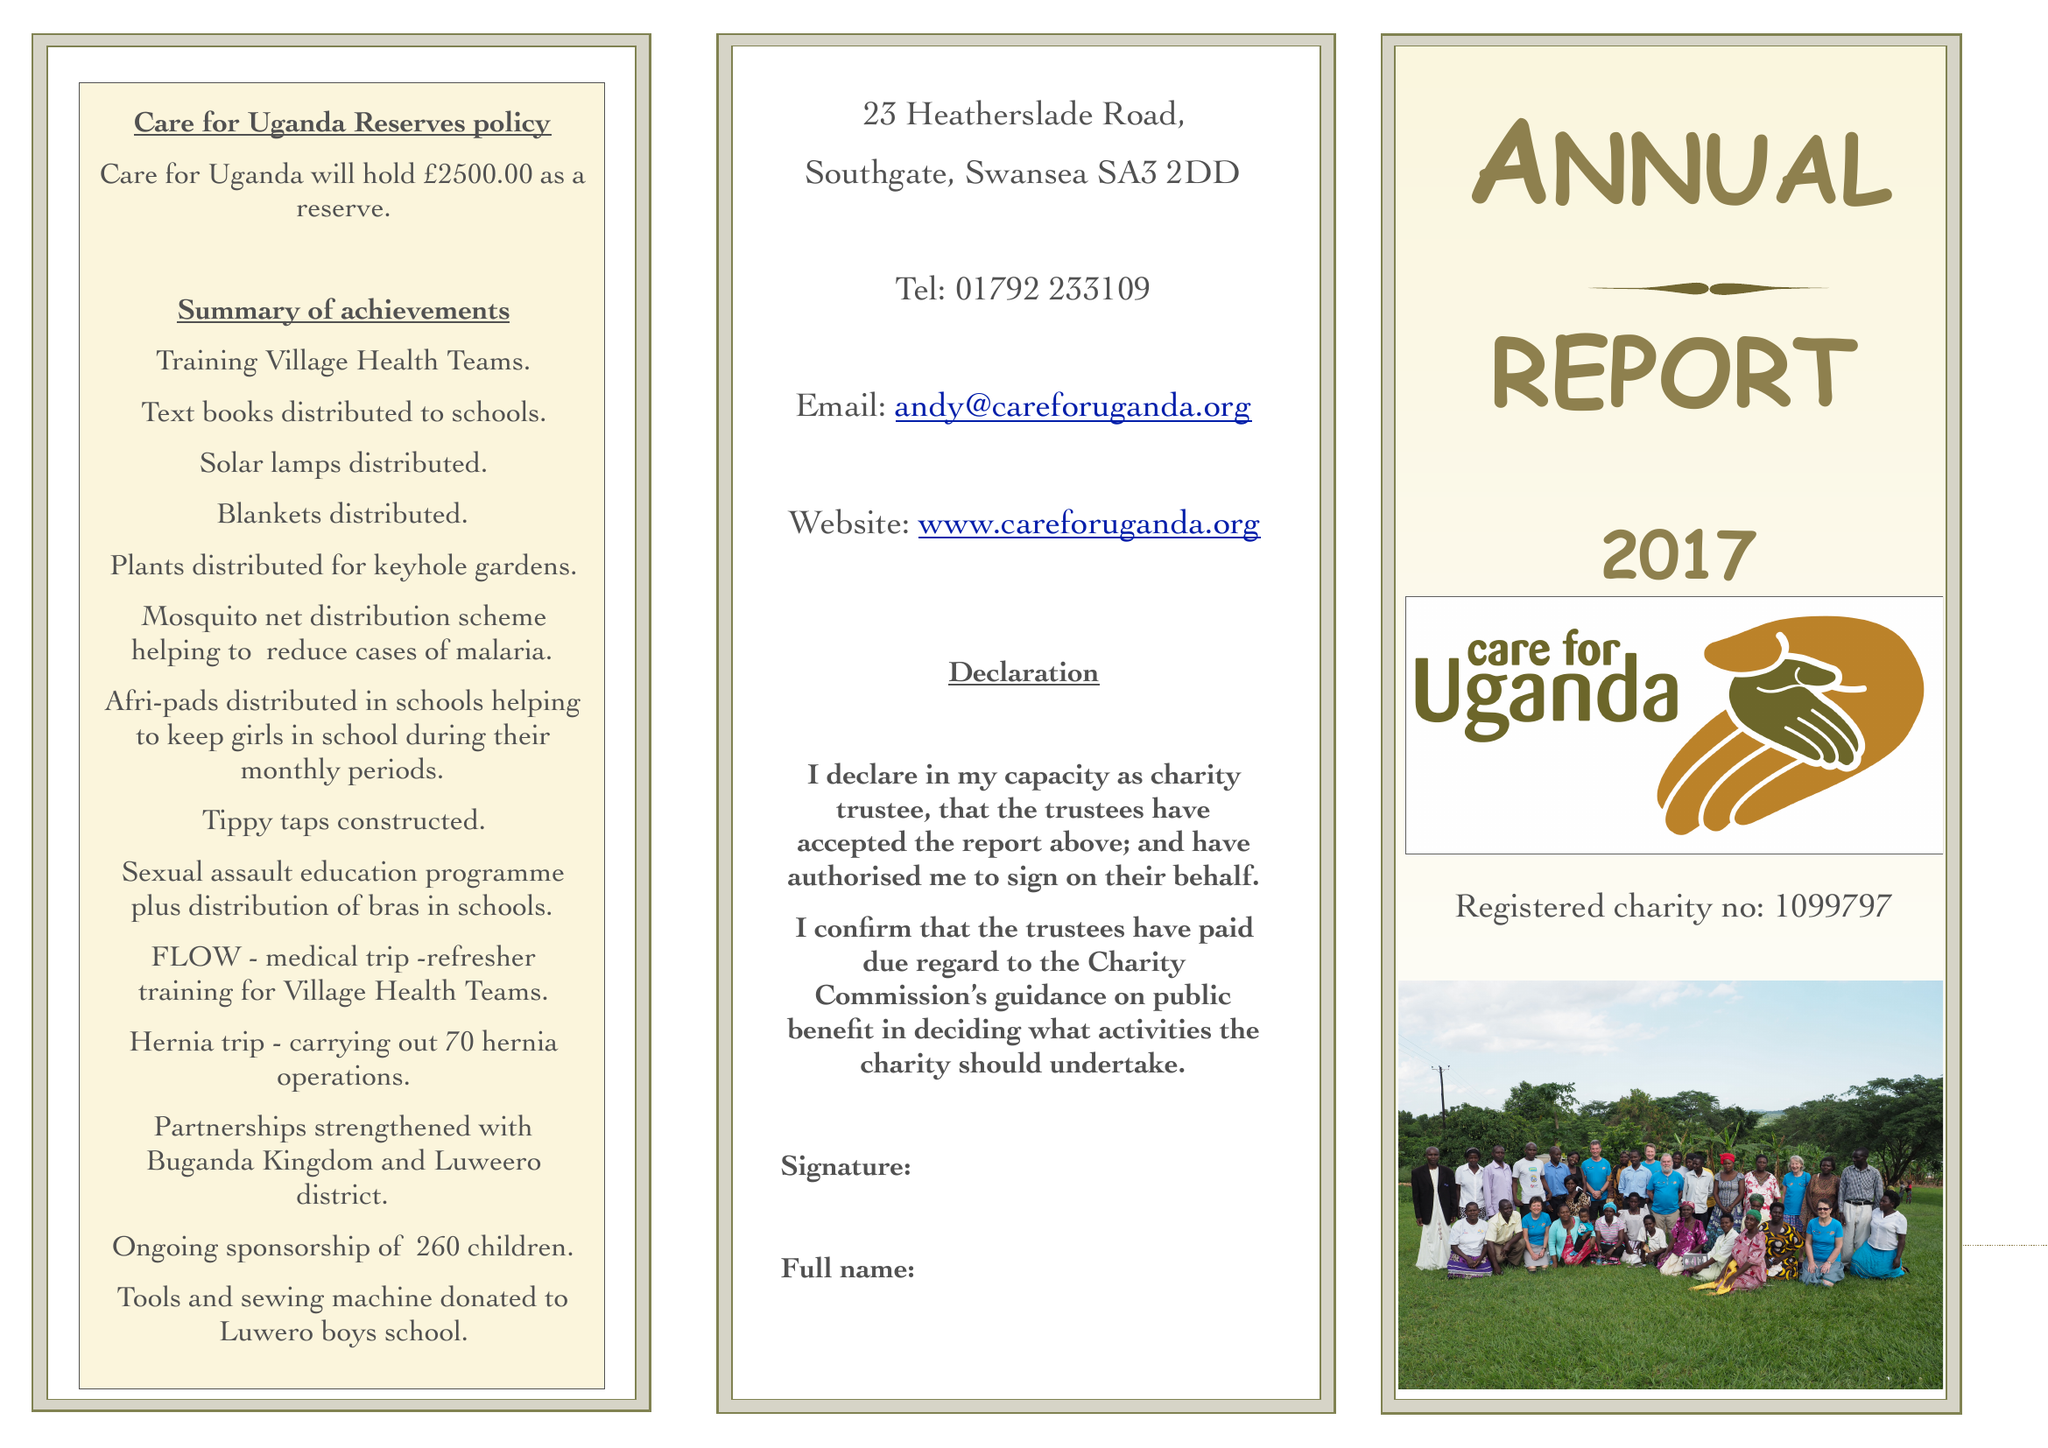What is the value for the address__street_line?
Answer the question using a single word or phrase. 23 HEATHERSLADE ROAD 